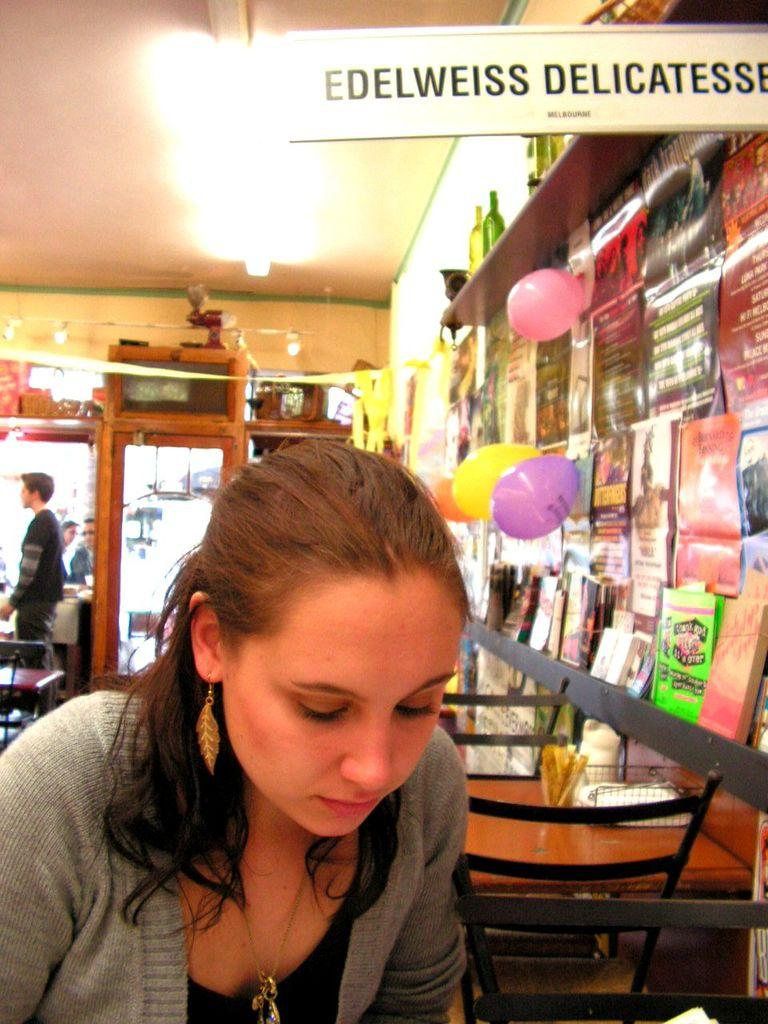What objects can be seen in the image? There are posts, bottles, and balloons in the image. Can you describe the woman in the image? There is a woman wearing an ash-colored coat in the image. What can be seen in the background of the image? There is a door, a person, and a chair in the background of the image. How is the image illuminated? The image is illuminated (alight). How many houses are visible in the image? There are no houses visible in the image. What type of table is present in the image? There is no table present in the image. 